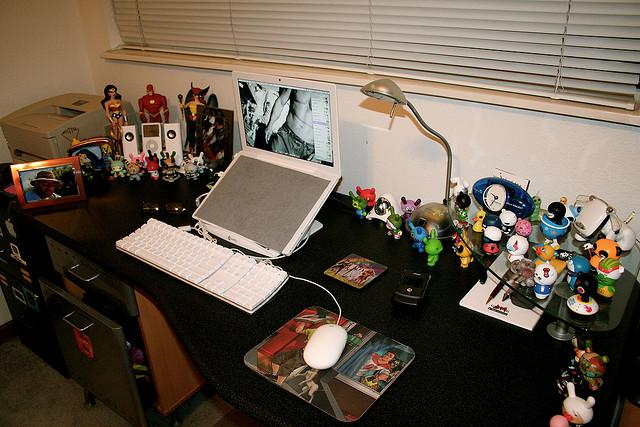Which female superhero is on the left corner of the desk? wonder woman 